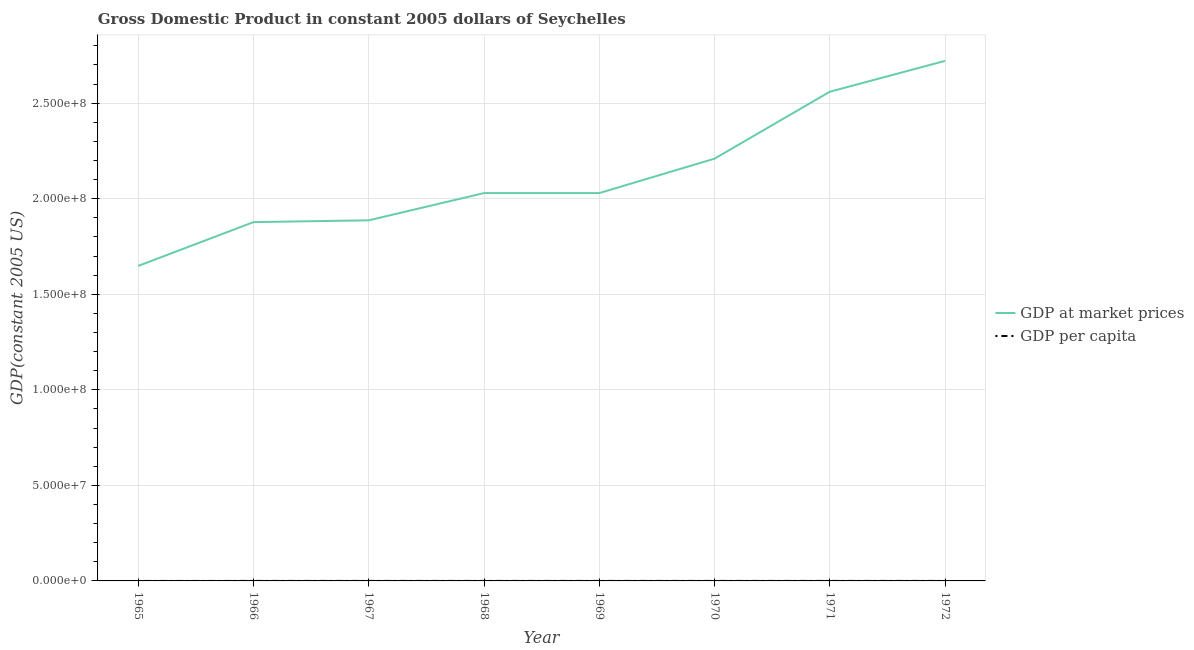How many different coloured lines are there?
Provide a succinct answer. 2. Does the line corresponding to gdp per capita intersect with the line corresponding to gdp at market prices?
Offer a terse response. No. Is the number of lines equal to the number of legend labels?
Give a very brief answer. Yes. What is the gdp per capita in 1971?
Your response must be concise. 4668. Across all years, what is the maximum gdp at market prices?
Provide a succinct answer. 2.72e+08. Across all years, what is the minimum gdp at market prices?
Your answer should be compact. 1.65e+08. In which year was the gdp at market prices maximum?
Your answer should be very brief. 1972. In which year was the gdp at market prices minimum?
Offer a very short reply. 1965. What is the total gdp at market prices in the graph?
Give a very brief answer. 1.70e+09. What is the difference between the gdp per capita in 1966 and that in 1972?
Your answer should be very brief. -998.2. What is the difference between the gdp per capita in 1972 and the gdp at market prices in 1970?
Your answer should be very brief. -2.21e+08. What is the average gdp per capita per year?
Make the answer very short. 4074.21. In the year 1969, what is the difference between the gdp per capita and gdp at market prices?
Provide a short and direct response. -2.03e+08. In how many years, is the gdp per capita greater than 260000000 US$?
Ensure brevity in your answer.  0. What is the ratio of the gdp per capita in 1967 to that in 1970?
Your answer should be compact. 0.92. Is the gdp per capita in 1965 less than that in 1969?
Your answer should be very brief. Yes. What is the difference between the highest and the second highest gdp per capita?
Ensure brevity in your answer.  185.34. What is the difference between the highest and the lowest gdp per capita?
Keep it short and to the point. 1383.13. In how many years, is the gdp per capita greater than the average gdp per capita taken over all years?
Offer a terse response. 3. Is the sum of the gdp at market prices in 1966 and 1968 greater than the maximum gdp per capita across all years?
Your answer should be very brief. Yes. Does the gdp per capita monotonically increase over the years?
Provide a succinct answer. No. Is the gdp at market prices strictly greater than the gdp per capita over the years?
Provide a short and direct response. Yes. What is the difference between two consecutive major ticks on the Y-axis?
Provide a succinct answer. 5.00e+07. Does the graph contain any zero values?
Your response must be concise. No. Does the graph contain grids?
Your response must be concise. Yes. How many legend labels are there?
Provide a succinct answer. 2. What is the title of the graph?
Offer a terse response. Gross Domestic Product in constant 2005 dollars of Seychelles. What is the label or title of the X-axis?
Your response must be concise. Year. What is the label or title of the Y-axis?
Provide a succinct answer. GDP(constant 2005 US). What is the GDP(constant 2005 US) of GDP at market prices in 1965?
Provide a short and direct response. 1.65e+08. What is the GDP(constant 2005 US) in GDP per capita in 1965?
Provide a short and direct response. 3470.21. What is the GDP(constant 2005 US) in GDP at market prices in 1966?
Your response must be concise. 1.88e+08. What is the GDP(constant 2005 US) in GDP per capita in 1966?
Your answer should be very brief. 3855.14. What is the GDP(constant 2005 US) in GDP at market prices in 1967?
Provide a short and direct response. 1.89e+08. What is the GDP(constant 2005 US) in GDP per capita in 1967?
Make the answer very short. 3780.51. What is the GDP(constant 2005 US) in GDP at market prices in 1968?
Provide a short and direct response. 2.03e+08. What is the GDP(constant 2005 US) of GDP per capita in 1968?
Keep it short and to the point. 3968.81. What is the GDP(constant 2005 US) in GDP at market prices in 1969?
Offer a very short reply. 2.03e+08. What is the GDP(constant 2005 US) in GDP per capita in 1969?
Offer a very short reply. 3875.51. What is the GDP(constant 2005 US) in GDP at market prices in 1970?
Your answer should be very brief. 2.21e+08. What is the GDP(constant 2005 US) in GDP per capita in 1970?
Give a very brief answer. 4122.12. What is the GDP(constant 2005 US) of GDP at market prices in 1971?
Ensure brevity in your answer.  2.56e+08. What is the GDP(constant 2005 US) in GDP per capita in 1971?
Ensure brevity in your answer.  4668. What is the GDP(constant 2005 US) of GDP at market prices in 1972?
Give a very brief answer. 2.72e+08. What is the GDP(constant 2005 US) in GDP per capita in 1972?
Your response must be concise. 4853.34. Across all years, what is the maximum GDP(constant 2005 US) in GDP at market prices?
Offer a very short reply. 2.72e+08. Across all years, what is the maximum GDP(constant 2005 US) in GDP per capita?
Keep it short and to the point. 4853.34. Across all years, what is the minimum GDP(constant 2005 US) in GDP at market prices?
Ensure brevity in your answer.  1.65e+08. Across all years, what is the minimum GDP(constant 2005 US) in GDP per capita?
Your response must be concise. 3470.21. What is the total GDP(constant 2005 US) in GDP at market prices in the graph?
Your response must be concise. 1.70e+09. What is the total GDP(constant 2005 US) in GDP per capita in the graph?
Your response must be concise. 3.26e+04. What is the difference between the GDP(constant 2005 US) in GDP at market prices in 1965 and that in 1966?
Make the answer very short. -2.29e+07. What is the difference between the GDP(constant 2005 US) in GDP per capita in 1965 and that in 1966?
Provide a succinct answer. -384.93. What is the difference between the GDP(constant 2005 US) of GDP at market prices in 1965 and that in 1967?
Make the answer very short. -2.39e+07. What is the difference between the GDP(constant 2005 US) of GDP per capita in 1965 and that in 1967?
Offer a terse response. -310.3. What is the difference between the GDP(constant 2005 US) in GDP at market prices in 1965 and that in 1968?
Ensure brevity in your answer.  -3.81e+07. What is the difference between the GDP(constant 2005 US) of GDP per capita in 1965 and that in 1968?
Ensure brevity in your answer.  -498.6. What is the difference between the GDP(constant 2005 US) of GDP at market prices in 1965 and that in 1969?
Provide a short and direct response. -3.81e+07. What is the difference between the GDP(constant 2005 US) of GDP per capita in 1965 and that in 1969?
Offer a terse response. -405.3. What is the difference between the GDP(constant 2005 US) of GDP at market prices in 1965 and that in 1970?
Ensure brevity in your answer.  -5.61e+07. What is the difference between the GDP(constant 2005 US) in GDP per capita in 1965 and that in 1970?
Provide a short and direct response. -651.91. What is the difference between the GDP(constant 2005 US) of GDP at market prices in 1965 and that in 1971?
Keep it short and to the point. -9.11e+07. What is the difference between the GDP(constant 2005 US) in GDP per capita in 1965 and that in 1971?
Offer a very short reply. -1197.79. What is the difference between the GDP(constant 2005 US) of GDP at market prices in 1965 and that in 1972?
Offer a very short reply. -1.07e+08. What is the difference between the GDP(constant 2005 US) of GDP per capita in 1965 and that in 1972?
Provide a succinct answer. -1383.13. What is the difference between the GDP(constant 2005 US) of GDP at market prices in 1966 and that in 1967?
Make the answer very short. -9.48e+05. What is the difference between the GDP(constant 2005 US) in GDP per capita in 1966 and that in 1967?
Provide a short and direct response. 74.63. What is the difference between the GDP(constant 2005 US) in GDP at market prices in 1966 and that in 1968?
Give a very brief answer. -1.52e+07. What is the difference between the GDP(constant 2005 US) in GDP per capita in 1966 and that in 1968?
Your answer should be very brief. -113.67. What is the difference between the GDP(constant 2005 US) of GDP at market prices in 1966 and that in 1969?
Your response must be concise. -1.52e+07. What is the difference between the GDP(constant 2005 US) in GDP per capita in 1966 and that in 1969?
Offer a terse response. -20.37. What is the difference between the GDP(constant 2005 US) in GDP at market prices in 1966 and that in 1970?
Keep it short and to the point. -3.32e+07. What is the difference between the GDP(constant 2005 US) in GDP per capita in 1966 and that in 1970?
Ensure brevity in your answer.  -266.98. What is the difference between the GDP(constant 2005 US) of GDP at market prices in 1966 and that in 1971?
Offer a very short reply. -6.82e+07. What is the difference between the GDP(constant 2005 US) in GDP per capita in 1966 and that in 1971?
Offer a very short reply. -812.86. What is the difference between the GDP(constant 2005 US) in GDP at market prices in 1966 and that in 1972?
Provide a short and direct response. -8.44e+07. What is the difference between the GDP(constant 2005 US) of GDP per capita in 1966 and that in 1972?
Give a very brief answer. -998.2. What is the difference between the GDP(constant 2005 US) of GDP at market prices in 1967 and that in 1968?
Your answer should be compact. -1.43e+07. What is the difference between the GDP(constant 2005 US) in GDP per capita in 1967 and that in 1968?
Your response must be concise. -188.3. What is the difference between the GDP(constant 2005 US) in GDP at market prices in 1967 and that in 1969?
Your answer should be compact. -1.43e+07. What is the difference between the GDP(constant 2005 US) in GDP per capita in 1967 and that in 1969?
Offer a very short reply. -95. What is the difference between the GDP(constant 2005 US) of GDP at market prices in 1967 and that in 1970?
Give a very brief answer. -3.23e+07. What is the difference between the GDP(constant 2005 US) in GDP per capita in 1967 and that in 1970?
Give a very brief answer. -341.61. What is the difference between the GDP(constant 2005 US) in GDP at market prices in 1967 and that in 1971?
Provide a short and direct response. -6.73e+07. What is the difference between the GDP(constant 2005 US) of GDP per capita in 1967 and that in 1971?
Provide a short and direct response. -887.49. What is the difference between the GDP(constant 2005 US) in GDP at market prices in 1967 and that in 1972?
Ensure brevity in your answer.  -8.34e+07. What is the difference between the GDP(constant 2005 US) of GDP per capita in 1967 and that in 1972?
Your answer should be compact. -1072.83. What is the difference between the GDP(constant 2005 US) in GDP per capita in 1968 and that in 1969?
Give a very brief answer. 93.3. What is the difference between the GDP(constant 2005 US) of GDP at market prices in 1968 and that in 1970?
Ensure brevity in your answer.  -1.80e+07. What is the difference between the GDP(constant 2005 US) of GDP per capita in 1968 and that in 1970?
Your answer should be compact. -153.31. What is the difference between the GDP(constant 2005 US) in GDP at market prices in 1968 and that in 1971?
Your answer should be very brief. -5.30e+07. What is the difference between the GDP(constant 2005 US) of GDP per capita in 1968 and that in 1971?
Ensure brevity in your answer.  -699.19. What is the difference between the GDP(constant 2005 US) in GDP at market prices in 1968 and that in 1972?
Offer a very short reply. -6.92e+07. What is the difference between the GDP(constant 2005 US) of GDP per capita in 1968 and that in 1972?
Provide a succinct answer. -884.53. What is the difference between the GDP(constant 2005 US) in GDP at market prices in 1969 and that in 1970?
Keep it short and to the point. -1.80e+07. What is the difference between the GDP(constant 2005 US) in GDP per capita in 1969 and that in 1970?
Ensure brevity in your answer.  -246.61. What is the difference between the GDP(constant 2005 US) in GDP at market prices in 1969 and that in 1971?
Offer a very short reply. -5.30e+07. What is the difference between the GDP(constant 2005 US) of GDP per capita in 1969 and that in 1971?
Ensure brevity in your answer.  -792.49. What is the difference between the GDP(constant 2005 US) in GDP at market prices in 1969 and that in 1972?
Ensure brevity in your answer.  -6.92e+07. What is the difference between the GDP(constant 2005 US) of GDP per capita in 1969 and that in 1972?
Ensure brevity in your answer.  -977.83. What is the difference between the GDP(constant 2005 US) of GDP at market prices in 1970 and that in 1971?
Make the answer very short. -3.50e+07. What is the difference between the GDP(constant 2005 US) of GDP per capita in 1970 and that in 1971?
Give a very brief answer. -545.87. What is the difference between the GDP(constant 2005 US) in GDP at market prices in 1970 and that in 1972?
Your answer should be compact. -5.12e+07. What is the difference between the GDP(constant 2005 US) in GDP per capita in 1970 and that in 1972?
Provide a succinct answer. -731.22. What is the difference between the GDP(constant 2005 US) of GDP at market prices in 1971 and that in 1972?
Offer a very short reply. -1.61e+07. What is the difference between the GDP(constant 2005 US) of GDP per capita in 1971 and that in 1972?
Make the answer very short. -185.34. What is the difference between the GDP(constant 2005 US) of GDP at market prices in 1965 and the GDP(constant 2005 US) of GDP per capita in 1966?
Offer a terse response. 1.65e+08. What is the difference between the GDP(constant 2005 US) in GDP at market prices in 1965 and the GDP(constant 2005 US) in GDP per capita in 1967?
Provide a short and direct response. 1.65e+08. What is the difference between the GDP(constant 2005 US) of GDP at market prices in 1965 and the GDP(constant 2005 US) of GDP per capita in 1968?
Ensure brevity in your answer.  1.65e+08. What is the difference between the GDP(constant 2005 US) of GDP at market prices in 1965 and the GDP(constant 2005 US) of GDP per capita in 1969?
Provide a succinct answer. 1.65e+08. What is the difference between the GDP(constant 2005 US) in GDP at market prices in 1965 and the GDP(constant 2005 US) in GDP per capita in 1970?
Offer a terse response. 1.65e+08. What is the difference between the GDP(constant 2005 US) of GDP at market prices in 1965 and the GDP(constant 2005 US) of GDP per capita in 1971?
Offer a terse response. 1.65e+08. What is the difference between the GDP(constant 2005 US) in GDP at market prices in 1965 and the GDP(constant 2005 US) in GDP per capita in 1972?
Your answer should be compact. 1.65e+08. What is the difference between the GDP(constant 2005 US) in GDP at market prices in 1966 and the GDP(constant 2005 US) in GDP per capita in 1967?
Your response must be concise. 1.88e+08. What is the difference between the GDP(constant 2005 US) in GDP at market prices in 1966 and the GDP(constant 2005 US) in GDP per capita in 1968?
Give a very brief answer. 1.88e+08. What is the difference between the GDP(constant 2005 US) in GDP at market prices in 1966 and the GDP(constant 2005 US) in GDP per capita in 1969?
Offer a very short reply. 1.88e+08. What is the difference between the GDP(constant 2005 US) of GDP at market prices in 1966 and the GDP(constant 2005 US) of GDP per capita in 1970?
Your response must be concise. 1.88e+08. What is the difference between the GDP(constant 2005 US) of GDP at market prices in 1966 and the GDP(constant 2005 US) of GDP per capita in 1971?
Give a very brief answer. 1.88e+08. What is the difference between the GDP(constant 2005 US) in GDP at market prices in 1966 and the GDP(constant 2005 US) in GDP per capita in 1972?
Your response must be concise. 1.88e+08. What is the difference between the GDP(constant 2005 US) in GDP at market prices in 1967 and the GDP(constant 2005 US) in GDP per capita in 1968?
Your response must be concise. 1.89e+08. What is the difference between the GDP(constant 2005 US) in GDP at market prices in 1967 and the GDP(constant 2005 US) in GDP per capita in 1969?
Provide a short and direct response. 1.89e+08. What is the difference between the GDP(constant 2005 US) of GDP at market prices in 1967 and the GDP(constant 2005 US) of GDP per capita in 1970?
Your answer should be very brief. 1.89e+08. What is the difference between the GDP(constant 2005 US) of GDP at market prices in 1967 and the GDP(constant 2005 US) of GDP per capita in 1971?
Keep it short and to the point. 1.89e+08. What is the difference between the GDP(constant 2005 US) in GDP at market prices in 1967 and the GDP(constant 2005 US) in GDP per capita in 1972?
Your response must be concise. 1.89e+08. What is the difference between the GDP(constant 2005 US) of GDP at market prices in 1968 and the GDP(constant 2005 US) of GDP per capita in 1969?
Offer a terse response. 2.03e+08. What is the difference between the GDP(constant 2005 US) in GDP at market prices in 1968 and the GDP(constant 2005 US) in GDP per capita in 1970?
Make the answer very short. 2.03e+08. What is the difference between the GDP(constant 2005 US) in GDP at market prices in 1968 and the GDP(constant 2005 US) in GDP per capita in 1971?
Ensure brevity in your answer.  2.03e+08. What is the difference between the GDP(constant 2005 US) in GDP at market prices in 1968 and the GDP(constant 2005 US) in GDP per capita in 1972?
Your answer should be compact. 2.03e+08. What is the difference between the GDP(constant 2005 US) of GDP at market prices in 1969 and the GDP(constant 2005 US) of GDP per capita in 1970?
Give a very brief answer. 2.03e+08. What is the difference between the GDP(constant 2005 US) in GDP at market prices in 1969 and the GDP(constant 2005 US) in GDP per capita in 1971?
Provide a short and direct response. 2.03e+08. What is the difference between the GDP(constant 2005 US) in GDP at market prices in 1969 and the GDP(constant 2005 US) in GDP per capita in 1972?
Ensure brevity in your answer.  2.03e+08. What is the difference between the GDP(constant 2005 US) of GDP at market prices in 1970 and the GDP(constant 2005 US) of GDP per capita in 1971?
Your answer should be compact. 2.21e+08. What is the difference between the GDP(constant 2005 US) in GDP at market prices in 1970 and the GDP(constant 2005 US) in GDP per capita in 1972?
Your answer should be very brief. 2.21e+08. What is the difference between the GDP(constant 2005 US) of GDP at market prices in 1971 and the GDP(constant 2005 US) of GDP per capita in 1972?
Ensure brevity in your answer.  2.56e+08. What is the average GDP(constant 2005 US) in GDP at market prices per year?
Provide a succinct answer. 2.12e+08. What is the average GDP(constant 2005 US) in GDP per capita per year?
Make the answer very short. 4074.21. In the year 1965, what is the difference between the GDP(constant 2005 US) of GDP at market prices and GDP(constant 2005 US) of GDP per capita?
Keep it short and to the point. 1.65e+08. In the year 1966, what is the difference between the GDP(constant 2005 US) in GDP at market prices and GDP(constant 2005 US) in GDP per capita?
Your answer should be very brief. 1.88e+08. In the year 1967, what is the difference between the GDP(constant 2005 US) of GDP at market prices and GDP(constant 2005 US) of GDP per capita?
Offer a very short reply. 1.89e+08. In the year 1968, what is the difference between the GDP(constant 2005 US) of GDP at market prices and GDP(constant 2005 US) of GDP per capita?
Your answer should be compact. 2.03e+08. In the year 1969, what is the difference between the GDP(constant 2005 US) of GDP at market prices and GDP(constant 2005 US) of GDP per capita?
Offer a terse response. 2.03e+08. In the year 1970, what is the difference between the GDP(constant 2005 US) in GDP at market prices and GDP(constant 2005 US) in GDP per capita?
Your answer should be compact. 2.21e+08. In the year 1971, what is the difference between the GDP(constant 2005 US) of GDP at market prices and GDP(constant 2005 US) of GDP per capita?
Make the answer very short. 2.56e+08. In the year 1972, what is the difference between the GDP(constant 2005 US) in GDP at market prices and GDP(constant 2005 US) in GDP per capita?
Make the answer very short. 2.72e+08. What is the ratio of the GDP(constant 2005 US) of GDP at market prices in 1965 to that in 1966?
Offer a very short reply. 0.88. What is the ratio of the GDP(constant 2005 US) in GDP per capita in 1965 to that in 1966?
Keep it short and to the point. 0.9. What is the ratio of the GDP(constant 2005 US) of GDP at market prices in 1965 to that in 1967?
Offer a terse response. 0.87. What is the ratio of the GDP(constant 2005 US) of GDP per capita in 1965 to that in 1967?
Provide a short and direct response. 0.92. What is the ratio of the GDP(constant 2005 US) of GDP at market prices in 1965 to that in 1968?
Keep it short and to the point. 0.81. What is the ratio of the GDP(constant 2005 US) in GDP per capita in 1965 to that in 1968?
Your response must be concise. 0.87. What is the ratio of the GDP(constant 2005 US) in GDP at market prices in 1965 to that in 1969?
Ensure brevity in your answer.  0.81. What is the ratio of the GDP(constant 2005 US) of GDP per capita in 1965 to that in 1969?
Your response must be concise. 0.9. What is the ratio of the GDP(constant 2005 US) in GDP at market prices in 1965 to that in 1970?
Make the answer very short. 0.75. What is the ratio of the GDP(constant 2005 US) of GDP per capita in 1965 to that in 1970?
Your response must be concise. 0.84. What is the ratio of the GDP(constant 2005 US) of GDP at market prices in 1965 to that in 1971?
Your response must be concise. 0.64. What is the ratio of the GDP(constant 2005 US) of GDP per capita in 1965 to that in 1971?
Your answer should be very brief. 0.74. What is the ratio of the GDP(constant 2005 US) in GDP at market prices in 1965 to that in 1972?
Provide a short and direct response. 0.61. What is the ratio of the GDP(constant 2005 US) of GDP per capita in 1965 to that in 1972?
Keep it short and to the point. 0.71. What is the ratio of the GDP(constant 2005 US) of GDP at market prices in 1966 to that in 1967?
Provide a short and direct response. 0.99. What is the ratio of the GDP(constant 2005 US) of GDP per capita in 1966 to that in 1967?
Make the answer very short. 1.02. What is the ratio of the GDP(constant 2005 US) in GDP at market prices in 1966 to that in 1968?
Keep it short and to the point. 0.93. What is the ratio of the GDP(constant 2005 US) in GDP per capita in 1966 to that in 1968?
Provide a short and direct response. 0.97. What is the ratio of the GDP(constant 2005 US) of GDP at market prices in 1966 to that in 1969?
Provide a short and direct response. 0.93. What is the ratio of the GDP(constant 2005 US) in GDP per capita in 1966 to that in 1969?
Keep it short and to the point. 0.99. What is the ratio of the GDP(constant 2005 US) of GDP at market prices in 1966 to that in 1970?
Offer a terse response. 0.85. What is the ratio of the GDP(constant 2005 US) of GDP per capita in 1966 to that in 1970?
Ensure brevity in your answer.  0.94. What is the ratio of the GDP(constant 2005 US) of GDP at market prices in 1966 to that in 1971?
Offer a terse response. 0.73. What is the ratio of the GDP(constant 2005 US) in GDP per capita in 1966 to that in 1971?
Your answer should be compact. 0.83. What is the ratio of the GDP(constant 2005 US) of GDP at market prices in 1966 to that in 1972?
Your response must be concise. 0.69. What is the ratio of the GDP(constant 2005 US) of GDP per capita in 1966 to that in 1972?
Provide a short and direct response. 0.79. What is the ratio of the GDP(constant 2005 US) in GDP at market prices in 1967 to that in 1968?
Provide a short and direct response. 0.93. What is the ratio of the GDP(constant 2005 US) in GDP per capita in 1967 to that in 1968?
Offer a very short reply. 0.95. What is the ratio of the GDP(constant 2005 US) in GDP at market prices in 1967 to that in 1969?
Make the answer very short. 0.93. What is the ratio of the GDP(constant 2005 US) of GDP per capita in 1967 to that in 1969?
Keep it short and to the point. 0.98. What is the ratio of the GDP(constant 2005 US) of GDP at market prices in 1967 to that in 1970?
Offer a terse response. 0.85. What is the ratio of the GDP(constant 2005 US) in GDP per capita in 1967 to that in 1970?
Keep it short and to the point. 0.92. What is the ratio of the GDP(constant 2005 US) in GDP at market prices in 1967 to that in 1971?
Ensure brevity in your answer.  0.74. What is the ratio of the GDP(constant 2005 US) of GDP per capita in 1967 to that in 1971?
Provide a succinct answer. 0.81. What is the ratio of the GDP(constant 2005 US) of GDP at market prices in 1967 to that in 1972?
Ensure brevity in your answer.  0.69. What is the ratio of the GDP(constant 2005 US) of GDP per capita in 1967 to that in 1972?
Provide a succinct answer. 0.78. What is the ratio of the GDP(constant 2005 US) of GDP at market prices in 1968 to that in 1969?
Your response must be concise. 1. What is the ratio of the GDP(constant 2005 US) in GDP per capita in 1968 to that in 1969?
Offer a terse response. 1.02. What is the ratio of the GDP(constant 2005 US) of GDP at market prices in 1968 to that in 1970?
Keep it short and to the point. 0.92. What is the ratio of the GDP(constant 2005 US) of GDP per capita in 1968 to that in 1970?
Keep it short and to the point. 0.96. What is the ratio of the GDP(constant 2005 US) of GDP at market prices in 1968 to that in 1971?
Provide a succinct answer. 0.79. What is the ratio of the GDP(constant 2005 US) in GDP per capita in 1968 to that in 1971?
Your answer should be very brief. 0.85. What is the ratio of the GDP(constant 2005 US) in GDP at market prices in 1968 to that in 1972?
Your response must be concise. 0.75. What is the ratio of the GDP(constant 2005 US) in GDP per capita in 1968 to that in 1972?
Your response must be concise. 0.82. What is the ratio of the GDP(constant 2005 US) in GDP at market prices in 1969 to that in 1970?
Your response must be concise. 0.92. What is the ratio of the GDP(constant 2005 US) of GDP per capita in 1969 to that in 1970?
Your answer should be very brief. 0.94. What is the ratio of the GDP(constant 2005 US) in GDP at market prices in 1969 to that in 1971?
Your answer should be very brief. 0.79. What is the ratio of the GDP(constant 2005 US) in GDP per capita in 1969 to that in 1971?
Your response must be concise. 0.83. What is the ratio of the GDP(constant 2005 US) in GDP at market prices in 1969 to that in 1972?
Keep it short and to the point. 0.75. What is the ratio of the GDP(constant 2005 US) of GDP per capita in 1969 to that in 1972?
Keep it short and to the point. 0.8. What is the ratio of the GDP(constant 2005 US) of GDP at market prices in 1970 to that in 1971?
Provide a succinct answer. 0.86. What is the ratio of the GDP(constant 2005 US) in GDP per capita in 1970 to that in 1971?
Provide a succinct answer. 0.88. What is the ratio of the GDP(constant 2005 US) in GDP at market prices in 1970 to that in 1972?
Your response must be concise. 0.81. What is the ratio of the GDP(constant 2005 US) in GDP per capita in 1970 to that in 1972?
Your answer should be compact. 0.85. What is the ratio of the GDP(constant 2005 US) of GDP at market prices in 1971 to that in 1972?
Offer a terse response. 0.94. What is the ratio of the GDP(constant 2005 US) of GDP per capita in 1971 to that in 1972?
Offer a terse response. 0.96. What is the difference between the highest and the second highest GDP(constant 2005 US) of GDP at market prices?
Ensure brevity in your answer.  1.61e+07. What is the difference between the highest and the second highest GDP(constant 2005 US) in GDP per capita?
Make the answer very short. 185.34. What is the difference between the highest and the lowest GDP(constant 2005 US) in GDP at market prices?
Keep it short and to the point. 1.07e+08. What is the difference between the highest and the lowest GDP(constant 2005 US) in GDP per capita?
Give a very brief answer. 1383.13. 